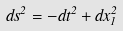<formula> <loc_0><loc_0><loc_500><loc_500>d s ^ { 2 } = - d t ^ { 2 } + d x _ { 1 } ^ { 2 }</formula> 